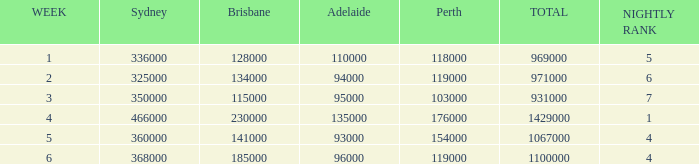What was the rating for Brisbane the week that Adelaide had 94000? 134000.0. 